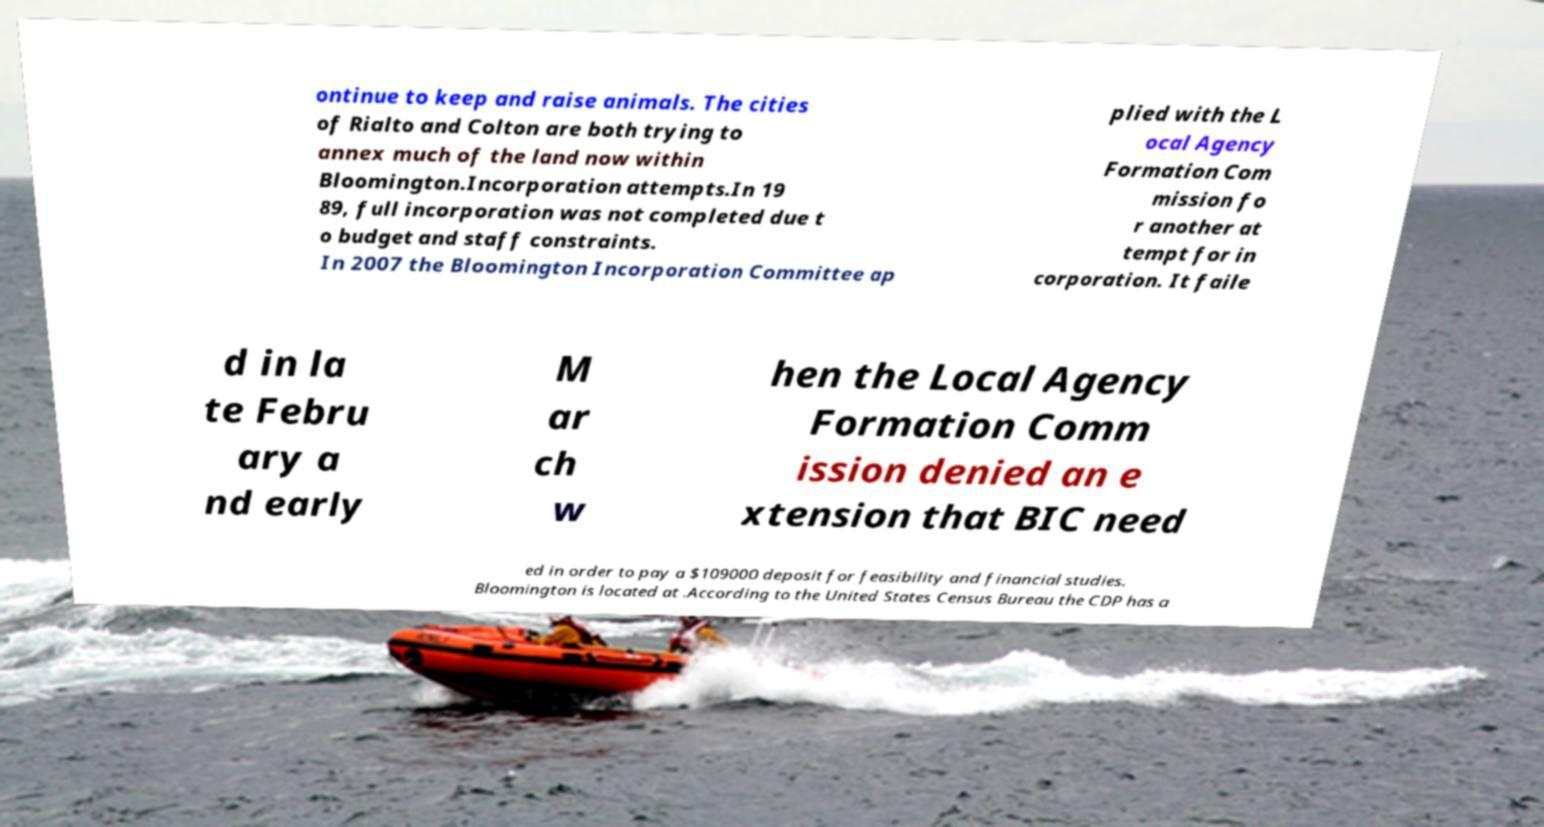There's text embedded in this image that I need extracted. Can you transcribe it verbatim? ontinue to keep and raise animals. The cities of Rialto and Colton are both trying to annex much of the land now within Bloomington.Incorporation attempts.In 19 89, full incorporation was not completed due t o budget and staff constraints. In 2007 the Bloomington Incorporation Committee ap plied with the L ocal Agency Formation Com mission fo r another at tempt for in corporation. It faile d in la te Febru ary a nd early M ar ch w hen the Local Agency Formation Comm ission denied an e xtension that BIC need ed in order to pay a $109000 deposit for feasibility and financial studies. Bloomington is located at .According to the United States Census Bureau the CDP has a 